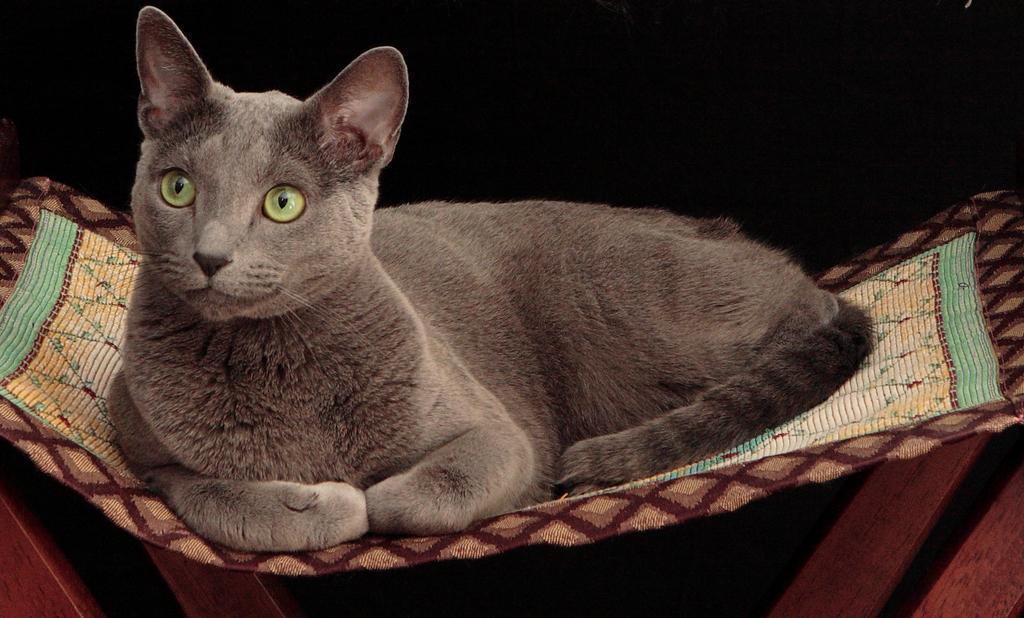In one or two sentences, can you explain what this image depicts? In this image a cat is sitting on a cloth. 